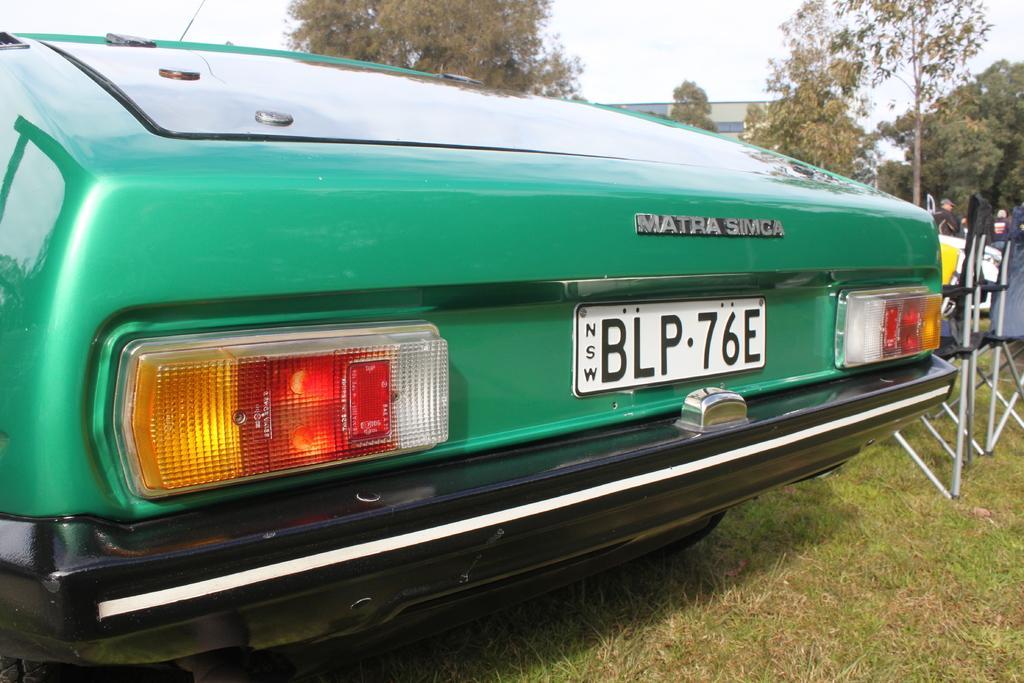Could you give a brief overview of what you see in this image? In this image there is a car on the surface of the grass. Beside the car there are chairs. At the background there is a building and trees. 